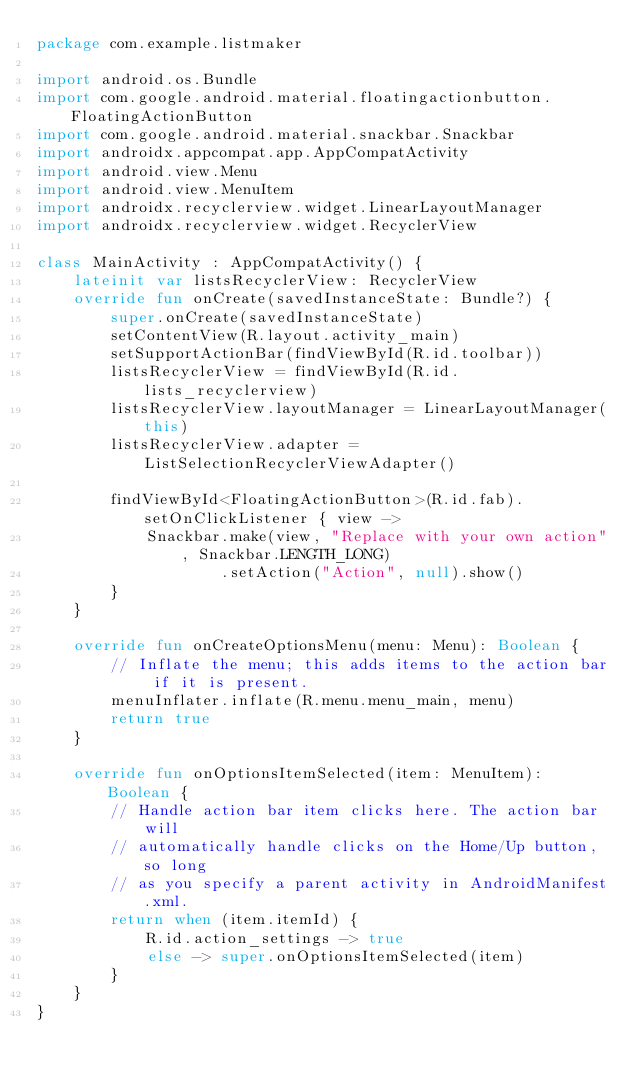<code> <loc_0><loc_0><loc_500><loc_500><_Kotlin_>package com.example.listmaker

import android.os.Bundle
import com.google.android.material.floatingactionbutton.FloatingActionButton
import com.google.android.material.snackbar.Snackbar
import androidx.appcompat.app.AppCompatActivity
import android.view.Menu
import android.view.MenuItem
import androidx.recyclerview.widget.LinearLayoutManager
import androidx.recyclerview.widget.RecyclerView

class MainActivity : AppCompatActivity() {
    lateinit var listsRecyclerView: RecyclerView
    override fun onCreate(savedInstanceState: Bundle?) {
        super.onCreate(savedInstanceState)
        setContentView(R.layout.activity_main)
        setSupportActionBar(findViewById(R.id.toolbar))
        listsRecyclerView = findViewById(R.id.lists_recyclerview)
        listsRecyclerView.layoutManager = LinearLayoutManager(this)
        listsRecyclerView.adapter = ListSelectionRecyclerViewAdapter()

        findViewById<FloatingActionButton>(R.id.fab).setOnClickListener { view ->
            Snackbar.make(view, "Replace with your own action", Snackbar.LENGTH_LONG)
                    .setAction("Action", null).show()
        }
    }

    override fun onCreateOptionsMenu(menu: Menu): Boolean {
        // Inflate the menu; this adds items to the action bar if it is present.
        menuInflater.inflate(R.menu.menu_main, menu)
        return true
    }

    override fun onOptionsItemSelected(item: MenuItem): Boolean {
        // Handle action bar item clicks here. The action bar will
        // automatically handle clicks on the Home/Up button, so long
        // as you specify a parent activity in AndroidManifest.xml.
        return when (item.itemId) {
            R.id.action_settings -> true
            else -> super.onOptionsItemSelected(item)
        }
    }
}</code> 